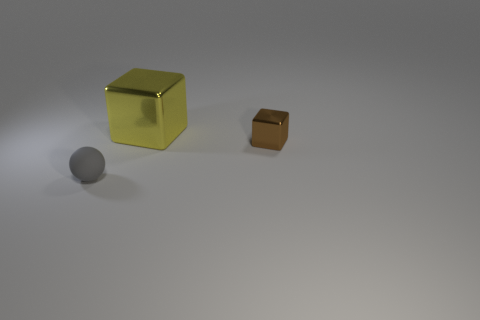Add 2 gray matte things. How many objects exist? 5 Subtract 1 gray balls. How many objects are left? 2 Subtract all blocks. How many objects are left? 1 Subtract all blue spheres. Subtract all yellow cylinders. How many spheres are left? 1 Subtract all yellow cubes. How many red balls are left? 0 Subtract all rubber objects. Subtract all tiny green shiny cylinders. How many objects are left? 2 Add 3 large yellow cubes. How many large yellow cubes are left? 4 Add 3 small gray balls. How many small gray balls exist? 4 